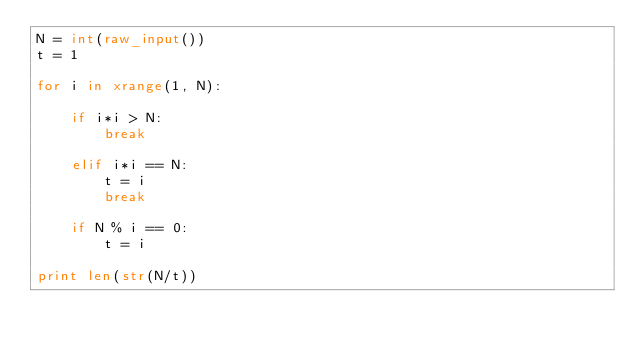Convert code to text. <code><loc_0><loc_0><loc_500><loc_500><_Python_>N = int(raw_input())
t = 1

for i in xrange(1, N):

    if i*i > N:
        break

    elif i*i == N:
        t = i
        break

    if N % i == 0:
        t = i

print len(str(N/t))</code> 